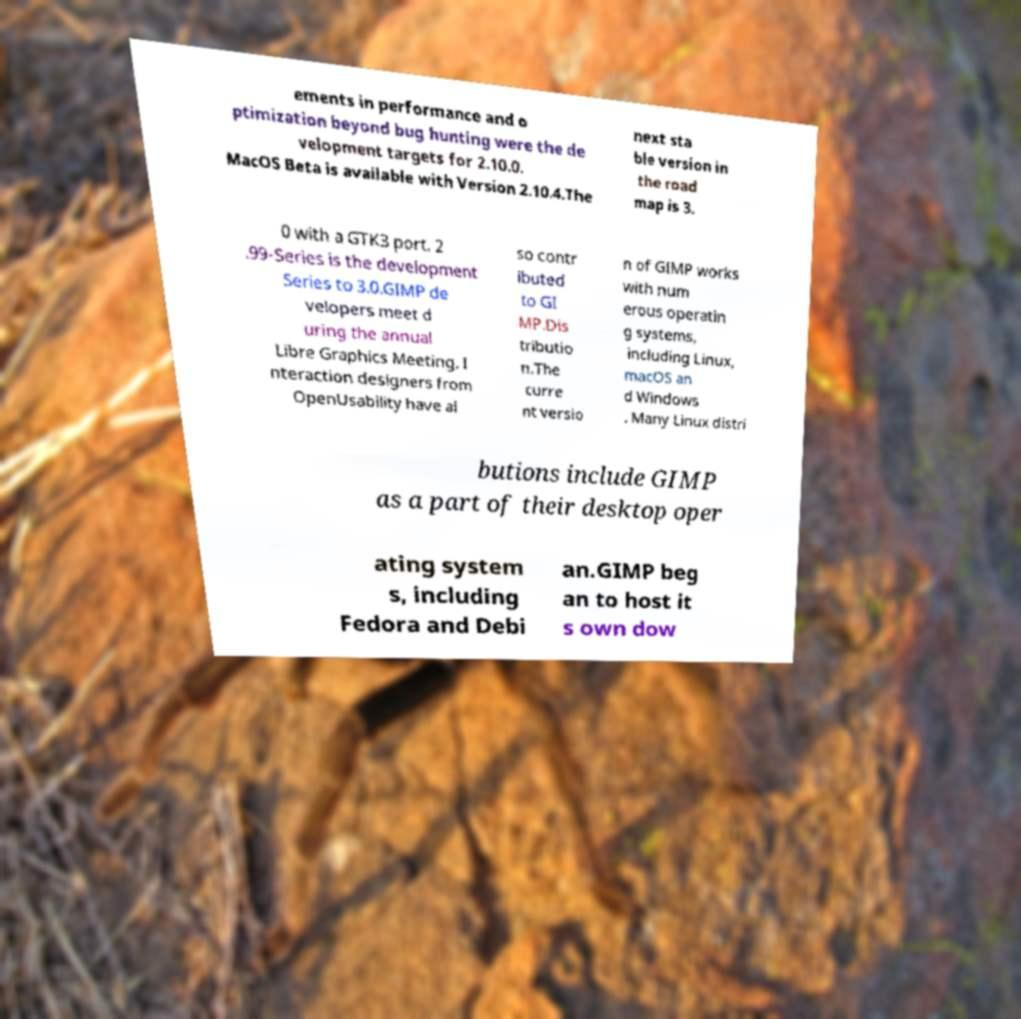Could you extract and type out the text from this image? ements in performance and o ptimization beyond bug hunting were the de velopment targets for 2.10.0. MacOS Beta is available with Version 2.10.4.The next sta ble version in the road map is 3. 0 with a GTK3 port. 2 .99-Series is the development Series to 3.0.GIMP de velopers meet d uring the annual Libre Graphics Meeting. I nteraction designers from OpenUsability have al so contr ibuted to GI MP.Dis tributio n.The curre nt versio n of GIMP works with num erous operatin g systems, including Linux, macOS an d Windows . Many Linux distri butions include GIMP as a part of their desktop oper ating system s, including Fedora and Debi an.GIMP beg an to host it s own dow 